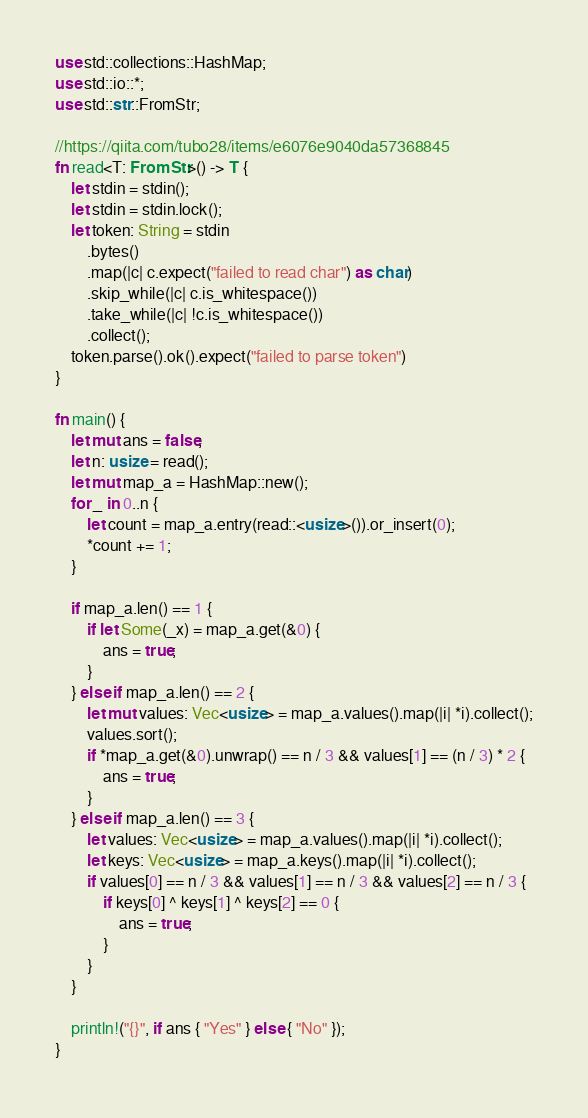<code> <loc_0><loc_0><loc_500><loc_500><_Rust_>use std::collections::HashMap;
use std::io::*;
use std::str::FromStr;

//https://qiita.com/tubo28/items/e6076e9040da57368845
fn read<T: FromStr>() -> T {
    let stdin = stdin();
    let stdin = stdin.lock();
    let token: String = stdin
        .bytes()
        .map(|c| c.expect("failed to read char") as char)
        .skip_while(|c| c.is_whitespace())
        .take_while(|c| !c.is_whitespace())
        .collect();
    token.parse().ok().expect("failed to parse token")
}

fn main() {
    let mut ans = false;
    let n: usize = read();
    let mut map_a = HashMap::new();
    for _ in 0..n {
        let count = map_a.entry(read::<usize>()).or_insert(0);
        *count += 1;
    }

    if map_a.len() == 1 {
        if let Some(_x) = map_a.get(&0) {
            ans = true;
        }
    } else if map_a.len() == 2 {
        let mut values: Vec<usize> = map_a.values().map(|i| *i).collect();
        values.sort();
        if *map_a.get(&0).unwrap() == n / 3 && values[1] == (n / 3) * 2 {
            ans = true;
        }
    } else if map_a.len() == 3 {
        let values: Vec<usize> = map_a.values().map(|i| *i).collect();
        let keys: Vec<usize> = map_a.keys().map(|i| *i).collect();
        if values[0] == n / 3 && values[1] == n / 3 && values[2] == n / 3 {
            if keys[0] ^ keys[1] ^ keys[2] == 0 {
                ans = true;
            }
        }
    }

    println!("{}", if ans { "Yes" } else { "No" });
}
</code> 